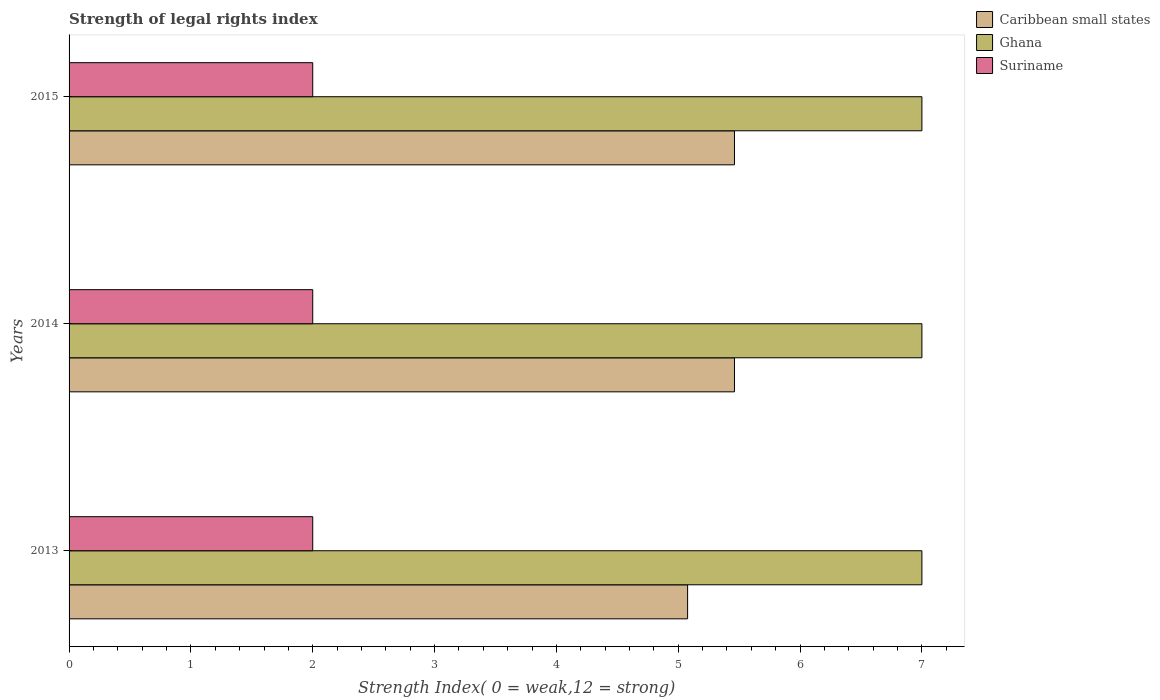How many groups of bars are there?
Your answer should be very brief. 3. Are the number of bars per tick equal to the number of legend labels?
Your answer should be compact. Yes. Are the number of bars on each tick of the Y-axis equal?
Ensure brevity in your answer.  Yes. How many bars are there on the 2nd tick from the top?
Provide a succinct answer. 3. What is the label of the 3rd group of bars from the top?
Your response must be concise. 2013. In how many cases, is the number of bars for a given year not equal to the number of legend labels?
Your response must be concise. 0. What is the strength index in Suriname in 2015?
Offer a terse response. 2. Across all years, what is the maximum strength index in Ghana?
Give a very brief answer. 7. Across all years, what is the minimum strength index in Caribbean small states?
Your response must be concise. 5.08. What is the total strength index in Ghana in the graph?
Ensure brevity in your answer.  21. What is the difference between the strength index in Caribbean small states in 2013 and that in 2015?
Your answer should be compact. -0.38. What is the difference between the strength index in Caribbean small states in 2014 and the strength index in Ghana in 2013?
Offer a terse response. -1.54. What is the average strength index in Suriname per year?
Offer a terse response. 2. In the year 2013, what is the difference between the strength index in Ghana and strength index in Caribbean small states?
Offer a terse response. 1.92. In how many years, is the strength index in Caribbean small states greater than 3.2 ?
Ensure brevity in your answer.  3. Is the strength index in Caribbean small states in 2013 less than that in 2014?
Offer a very short reply. Yes. What is the difference between the highest and the second highest strength index in Suriname?
Give a very brief answer. 0. Is the sum of the strength index in Ghana in 2013 and 2015 greater than the maximum strength index in Caribbean small states across all years?
Your answer should be very brief. Yes. What does the 2nd bar from the top in 2014 represents?
Give a very brief answer. Ghana. What does the 3rd bar from the bottom in 2015 represents?
Offer a very short reply. Suriname. Is it the case that in every year, the sum of the strength index in Suriname and strength index in Caribbean small states is greater than the strength index in Ghana?
Keep it short and to the point. Yes. Are all the bars in the graph horizontal?
Give a very brief answer. Yes. Are the values on the major ticks of X-axis written in scientific E-notation?
Ensure brevity in your answer.  No. Does the graph contain any zero values?
Your response must be concise. No. Where does the legend appear in the graph?
Make the answer very short. Top right. How are the legend labels stacked?
Give a very brief answer. Vertical. What is the title of the graph?
Your answer should be very brief. Strength of legal rights index. What is the label or title of the X-axis?
Provide a short and direct response. Strength Index( 0 = weak,12 = strong). What is the Strength Index( 0 = weak,12 = strong) of Caribbean small states in 2013?
Your answer should be compact. 5.08. What is the Strength Index( 0 = weak,12 = strong) in Caribbean small states in 2014?
Provide a short and direct response. 5.46. What is the Strength Index( 0 = weak,12 = strong) in Caribbean small states in 2015?
Make the answer very short. 5.46. What is the Strength Index( 0 = weak,12 = strong) in Ghana in 2015?
Offer a terse response. 7. Across all years, what is the maximum Strength Index( 0 = weak,12 = strong) of Caribbean small states?
Offer a terse response. 5.46. Across all years, what is the minimum Strength Index( 0 = weak,12 = strong) in Caribbean small states?
Offer a very short reply. 5.08. Across all years, what is the minimum Strength Index( 0 = weak,12 = strong) in Ghana?
Your response must be concise. 7. Across all years, what is the minimum Strength Index( 0 = weak,12 = strong) of Suriname?
Offer a terse response. 2. What is the total Strength Index( 0 = weak,12 = strong) in Caribbean small states in the graph?
Give a very brief answer. 16. What is the total Strength Index( 0 = weak,12 = strong) of Ghana in the graph?
Provide a succinct answer. 21. What is the difference between the Strength Index( 0 = weak,12 = strong) in Caribbean small states in 2013 and that in 2014?
Give a very brief answer. -0.38. What is the difference between the Strength Index( 0 = weak,12 = strong) in Ghana in 2013 and that in 2014?
Provide a short and direct response. 0. What is the difference between the Strength Index( 0 = weak,12 = strong) in Caribbean small states in 2013 and that in 2015?
Give a very brief answer. -0.38. What is the difference between the Strength Index( 0 = weak,12 = strong) of Suriname in 2013 and that in 2015?
Offer a very short reply. 0. What is the difference between the Strength Index( 0 = weak,12 = strong) in Ghana in 2014 and that in 2015?
Your response must be concise. 0. What is the difference between the Strength Index( 0 = weak,12 = strong) of Suriname in 2014 and that in 2015?
Keep it short and to the point. 0. What is the difference between the Strength Index( 0 = weak,12 = strong) of Caribbean small states in 2013 and the Strength Index( 0 = weak,12 = strong) of Ghana in 2014?
Your response must be concise. -1.92. What is the difference between the Strength Index( 0 = weak,12 = strong) in Caribbean small states in 2013 and the Strength Index( 0 = weak,12 = strong) in Suriname in 2014?
Keep it short and to the point. 3.08. What is the difference between the Strength Index( 0 = weak,12 = strong) in Caribbean small states in 2013 and the Strength Index( 0 = weak,12 = strong) in Ghana in 2015?
Make the answer very short. -1.92. What is the difference between the Strength Index( 0 = weak,12 = strong) of Caribbean small states in 2013 and the Strength Index( 0 = weak,12 = strong) of Suriname in 2015?
Provide a short and direct response. 3.08. What is the difference between the Strength Index( 0 = weak,12 = strong) in Ghana in 2013 and the Strength Index( 0 = weak,12 = strong) in Suriname in 2015?
Offer a terse response. 5. What is the difference between the Strength Index( 0 = weak,12 = strong) of Caribbean small states in 2014 and the Strength Index( 0 = weak,12 = strong) of Ghana in 2015?
Provide a succinct answer. -1.54. What is the difference between the Strength Index( 0 = weak,12 = strong) of Caribbean small states in 2014 and the Strength Index( 0 = weak,12 = strong) of Suriname in 2015?
Make the answer very short. 3.46. What is the difference between the Strength Index( 0 = weak,12 = strong) in Ghana in 2014 and the Strength Index( 0 = weak,12 = strong) in Suriname in 2015?
Your response must be concise. 5. What is the average Strength Index( 0 = weak,12 = strong) in Caribbean small states per year?
Provide a succinct answer. 5.33. In the year 2013, what is the difference between the Strength Index( 0 = weak,12 = strong) of Caribbean small states and Strength Index( 0 = weak,12 = strong) of Ghana?
Offer a terse response. -1.92. In the year 2013, what is the difference between the Strength Index( 0 = weak,12 = strong) of Caribbean small states and Strength Index( 0 = weak,12 = strong) of Suriname?
Your response must be concise. 3.08. In the year 2014, what is the difference between the Strength Index( 0 = weak,12 = strong) in Caribbean small states and Strength Index( 0 = weak,12 = strong) in Ghana?
Your response must be concise. -1.54. In the year 2014, what is the difference between the Strength Index( 0 = weak,12 = strong) of Caribbean small states and Strength Index( 0 = weak,12 = strong) of Suriname?
Provide a succinct answer. 3.46. In the year 2014, what is the difference between the Strength Index( 0 = weak,12 = strong) of Ghana and Strength Index( 0 = weak,12 = strong) of Suriname?
Your response must be concise. 5. In the year 2015, what is the difference between the Strength Index( 0 = weak,12 = strong) in Caribbean small states and Strength Index( 0 = weak,12 = strong) in Ghana?
Give a very brief answer. -1.54. In the year 2015, what is the difference between the Strength Index( 0 = weak,12 = strong) in Caribbean small states and Strength Index( 0 = weak,12 = strong) in Suriname?
Ensure brevity in your answer.  3.46. In the year 2015, what is the difference between the Strength Index( 0 = weak,12 = strong) of Ghana and Strength Index( 0 = weak,12 = strong) of Suriname?
Your answer should be very brief. 5. What is the ratio of the Strength Index( 0 = weak,12 = strong) in Caribbean small states in 2013 to that in 2014?
Offer a terse response. 0.93. What is the ratio of the Strength Index( 0 = weak,12 = strong) in Ghana in 2013 to that in 2014?
Your answer should be very brief. 1. What is the ratio of the Strength Index( 0 = weak,12 = strong) in Suriname in 2013 to that in 2014?
Your answer should be compact. 1. What is the ratio of the Strength Index( 0 = weak,12 = strong) in Caribbean small states in 2013 to that in 2015?
Make the answer very short. 0.93. What is the ratio of the Strength Index( 0 = weak,12 = strong) in Ghana in 2013 to that in 2015?
Your answer should be compact. 1. What is the ratio of the Strength Index( 0 = weak,12 = strong) in Suriname in 2013 to that in 2015?
Offer a very short reply. 1. What is the ratio of the Strength Index( 0 = weak,12 = strong) of Ghana in 2014 to that in 2015?
Your answer should be very brief. 1. What is the difference between the highest and the second highest Strength Index( 0 = weak,12 = strong) of Caribbean small states?
Give a very brief answer. 0. What is the difference between the highest and the second highest Strength Index( 0 = weak,12 = strong) of Ghana?
Keep it short and to the point. 0. What is the difference between the highest and the lowest Strength Index( 0 = weak,12 = strong) of Caribbean small states?
Offer a very short reply. 0.38. What is the difference between the highest and the lowest Strength Index( 0 = weak,12 = strong) of Ghana?
Your answer should be compact. 0. What is the difference between the highest and the lowest Strength Index( 0 = weak,12 = strong) in Suriname?
Keep it short and to the point. 0. 